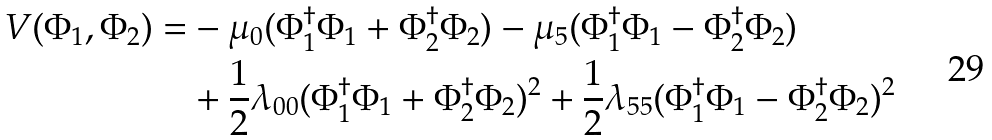Convert formula to latex. <formula><loc_0><loc_0><loc_500><loc_500>V ( \Phi _ { 1 } , \Phi _ { 2 } ) = & - \mu _ { 0 } ( \Phi _ { 1 } ^ { \dagger } \Phi _ { 1 } + \Phi _ { 2 } ^ { \dagger } \Phi _ { 2 } ) - \mu _ { 5 } ( \Phi _ { 1 } ^ { \dagger } \Phi _ { 1 } - \Phi _ { 2 } ^ { \dagger } \Phi _ { 2 } ) \\ & + \frac { 1 } { 2 } \lambda _ { 0 0 } ( \Phi _ { 1 } ^ { \dagger } \Phi _ { 1 } + \Phi _ { 2 } ^ { \dagger } \Phi _ { 2 } ) ^ { 2 } + \frac { 1 } { 2 } \lambda _ { 5 5 } ( \Phi _ { 1 } ^ { \dagger } \Phi _ { 1 } - \Phi _ { 2 } ^ { \dagger } \Phi _ { 2 } ) ^ { 2 }</formula> 